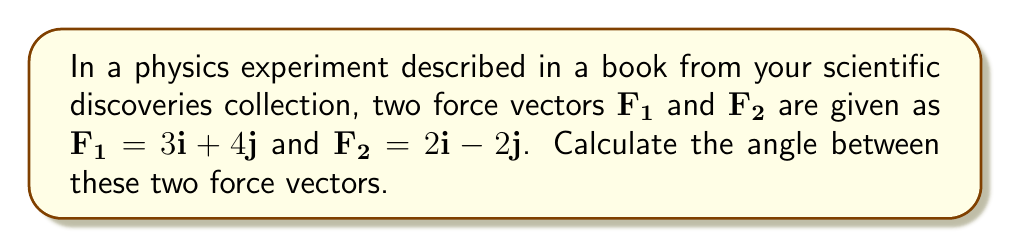Solve this math problem. To find the angle between two vectors, we can use the dot product formula:

$$\cos \theta = \frac{\mathbf{F_1} \cdot \mathbf{F_2}}{|\mathbf{F_1}||\mathbf{F_2}|}$$

Step 1: Calculate the dot product $\mathbf{F_1} \cdot \mathbf{F_2}$
$$\mathbf{F_1} \cdot \mathbf{F_2} = (3)(2) + (4)(-2) = 6 - 8 = -2$$

Step 2: Calculate the magnitudes of the vectors
$$|\mathbf{F_1}| = \sqrt{3^2 + 4^2} = \sqrt{9 + 16} = \sqrt{25} = 5$$
$$|\mathbf{F_2}| = \sqrt{2^2 + (-2)^2} = \sqrt{4 + 4} = \sqrt{8} = 2\sqrt{2}$$

Step 3: Substitute into the dot product formula
$$\cos \theta = \frac{-2}{(5)(2\sqrt{2})} = \frac{-2}{10\sqrt{2}}$$

Step 4: Solve for $\theta$ using the inverse cosine function
$$\theta = \arccos\left(\frac{-2}{10\sqrt{2}}\right) \approx 1.8235 \text{ radians}$$

Step 5: Convert to degrees
$$\theta \approx 1.8235 \times \frac{180^{\circ}}{\pi} \approx 104.48^{\circ}$$
Answer: $104.48^{\circ}$ 